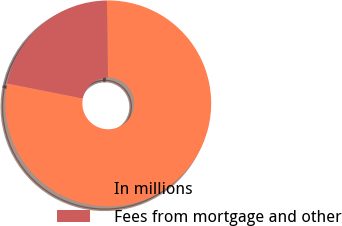<chart> <loc_0><loc_0><loc_500><loc_500><pie_chart><fcel>In millions<fcel>Fees from mortgage and other<nl><fcel>78.32%<fcel>21.68%<nl></chart> 